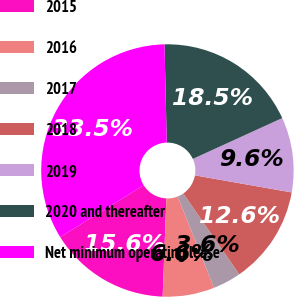Convert chart to OTSL. <chart><loc_0><loc_0><loc_500><loc_500><pie_chart><fcel>2015<fcel>2016<fcel>2017<fcel>2018<fcel>2019<fcel>2020 and thereafter<fcel>Net minimum operating lease<nl><fcel>15.56%<fcel>6.61%<fcel>3.63%<fcel>12.58%<fcel>9.6%<fcel>18.55%<fcel>33.47%<nl></chart> 